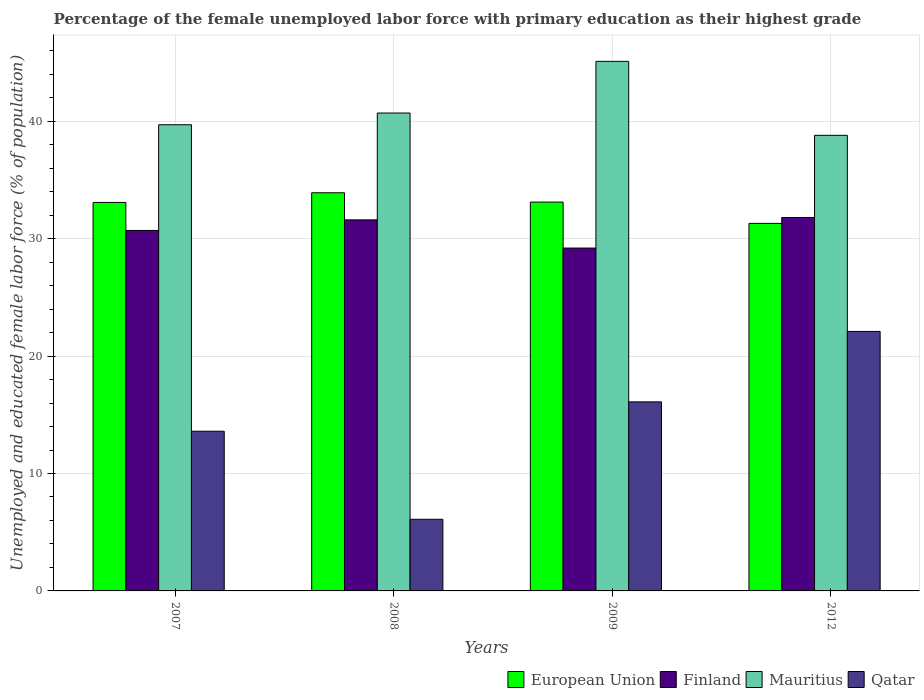How many different coloured bars are there?
Ensure brevity in your answer.  4. Are the number of bars per tick equal to the number of legend labels?
Offer a very short reply. Yes. How many bars are there on the 3rd tick from the left?
Your response must be concise. 4. What is the label of the 1st group of bars from the left?
Ensure brevity in your answer.  2007. What is the percentage of the unemployed female labor force with primary education in Finland in 2007?
Make the answer very short. 30.7. Across all years, what is the maximum percentage of the unemployed female labor force with primary education in Mauritius?
Your answer should be very brief. 45.1. Across all years, what is the minimum percentage of the unemployed female labor force with primary education in Finland?
Provide a succinct answer. 29.2. In which year was the percentage of the unemployed female labor force with primary education in Mauritius maximum?
Provide a succinct answer. 2009. In which year was the percentage of the unemployed female labor force with primary education in Finland minimum?
Give a very brief answer. 2009. What is the total percentage of the unemployed female labor force with primary education in Finland in the graph?
Offer a very short reply. 123.3. What is the difference between the percentage of the unemployed female labor force with primary education in Finland in 2008 and that in 2009?
Provide a succinct answer. 2.4. What is the difference between the percentage of the unemployed female labor force with primary education in Mauritius in 2008 and the percentage of the unemployed female labor force with primary education in Finland in 2012?
Your answer should be very brief. 8.9. What is the average percentage of the unemployed female labor force with primary education in European Union per year?
Keep it short and to the point. 32.85. In the year 2008, what is the difference between the percentage of the unemployed female labor force with primary education in Qatar and percentage of the unemployed female labor force with primary education in Mauritius?
Your response must be concise. -34.6. In how many years, is the percentage of the unemployed female labor force with primary education in Finland greater than 30 %?
Your response must be concise. 3. What is the ratio of the percentage of the unemployed female labor force with primary education in Mauritius in 2008 to that in 2009?
Make the answer very short. 0.9. Is the percentage of the unemployed female labor force with primary education in Finland in 2009 less than that in 2012?
Your answer should be compact. Yes. Is the difference between the percentage of the unemployed female labor force with primary education in Qatar in 2009 and 2012 greater than the difference between the percentage of the unemployed female labor force with primary education in Mauritius in 2009 and 2012?
Make the answer very short. No. What is the difference between the highest and the second highest percentage of the unemployed female labor force with primary education in Mauritius?
Your answer should be compact. 4.4. What is the difference between the highest and the lowest percentage of the unemployed female labor force with primary education in Qatar?
Your response must be concise. 16. In how many years, is the percentage of the unemployed female labor force with primary education in Qatar greater than the average percentage of the unemployed female labor force with primary education in Qatar taken over all years?
Provide a short and direct response. 2. Is the sum of the percentage of the unemployed female labor force with primary education in Finland in 2008 and 2009 greater than the maximum percentage of the unemployed female labor force with primary education in Mauritius across all years?
Offer a terse response. Yes. Is it the case that in every year, the sum of the percentage of the unemployed female labor force with primary education in European Union and percentage of the unemployed female labor force with primary education in Qatar is greater than the sum of percentage of the unemployed female labor force with primary education in Finland and percentage of the unemployed female labor force with primary education in Mauritius?
Offer a terse response. No. What does the 3rd bar from the right in 2008 represents?
Ensure brevity in your answer.  Finland. Is it the case that in every year, the sum of the percentage of the unemployed female labor force with primary education in Finland and percentage of the unemployed female labor force with primary education in Mauritius is greater than the percentage of the unemployed female labor force with primary education in Qatar?
Provide a succinct answer. Yes. What is the difference between two consecutive major ticks on the Y-axis?
Your answer should be compact. 10. How many legend labels are there?
Your answer should be very brief. 4. What is the title of the graph?
Ensure brevity in your answer.  Percentage of the female unemployed labor force with primary education as their highest grade. What is the label or title of the X-axis?
Ensure brevity in your answer.  Years. What is the label or title of the Y-axis?
Keep it short and to the point. Unemployed and educated female labor force (% of population). What is the Unemployed and educated female labor force (% of population) of European Union in 2007?
Offer a terse response. 33.08. What is the Unemployed and educated female labor force (% of population) in Finland in 2007?
Offer a very short reply. 30.7. What is the Unemployed and educated female labor force (% of population) in Mauritius in 2007?
Keep it short and to the point. 39.7. What is the Unemployed and educated female labor force (% of population) of Qatar in 2007?
Give a very brief answer. 13.6. What is the Unemployed and educated female labor force (% of population) in European Union in 2008?
Make the answer very short. 33.91. What is the Unemployed and educated female labor force (% of population) of Finland in 2008?
Your answer should be very brief. 31.6. What is the Unemployed and educated female labor force (% of population) of Mauritius in 2008?
Offer a very short reply. 40.7. What is the Unemployed and educated female labor force (% of population) in Qatar in 2008?
Make the answer very short. 6.1. What is the Unemployed and educated female labor force (% of population) of European Union in 2009?
Provide a succinct answer. 33.11. What is the Unemployed and educated female labor force (% of population) in Finland in 2009?
Make the answer very short. 29.2. What is the Unemployed and educated female labor force (% of population) of Mauritius in 2009?
Your response must be concise. 45.1. What is the Unemployed and educated female labor force (% of population) of Qatar in 2009?
Ensure brevity in your answer.  16.1. What is the Unemployed and educated female labor force (% of population) of European Union in 2012?
Offer a very short reply. 31.3. What is the Unemployed and educated female labor force (% of population) in Finland in 2012?
Ensure brevity in your answer.  31.8. What is the Unemployed and educated female labor force (% of population) in Mauritius in 2012?
Keep it short and to the point. 38.8. What is the Unemployed and educated female labor force (% of population) in Qatar in 2012?
Ensure brevity in your answer.  22.1. Across all years, what is the maximum Unemployed and educated female labor force (% of population) in European Union?
Your answer should be very brief. 33.91. Across all years, what is the maximum Unemployed and educated female labor force (% of population) of Finland?
Give a very brief answer. 31.8. Across all years, what is the maximum Unemployed and educated female labor force (% of population) of Mauritius?
Give a very brief answer. 45.1. Across all years, what is the maximum Unemployed and educated female labor force (% of population) of Qatar?
Keep it short and to the point. 22.1. Across all years, what is the minimum Unemployed and educated female labor force (% of population) of European Union?
Your answer should be very brief. 31.3. Across all years, what is the minimum Unemployed and educated female labor force (% of population) of Finland?
Ensure brevity in your answer.  29.2. Across all years, what is the minimum Unemployed and educated female labor force (% of population) in Mauritius?
Give a very brief answer. 38.8. Across all years, what is the minimum Unemployed and educated female labor force (% of population) in Qatar?
Provide a succinct answer. 6.1. What is the total Unemployed and educated female labor force (% of population) in European Union in the graph?
Your answer should be very brief. 131.41. What is the total Unemployed and educated female labor force (% of population) of Finland in the graph?
Offer a terse response. 123.3. What is the total Unemployed and educated female labor force (% of population) in Mauritius in the graph?
Give a very brief answer. 164.3. What is the total Unemployed and educated female labor force (% of population) of Qatar in the graph?
Keep it short and to the point. 57.9. What is the difference between the Unemployed and educated female labor force (% of population) in European Union in 2007 and that in 2008?
Your answer should be very brief. -0.82. What is the difference between the Unemployed and educated female labor force (% of population) in European Union in 2007 and that in 2009?
Provide a succinct answer. -0.03. What is the difference between the Unemployed and educated female labor force (% of population) in Finland in 2007 and that in 2009?
Provide a short and direct response. 1.5. What is the difference between the Unemployed and educated female labor force (% of population) in Mauritius in 2007 and that in 2009?
Provide a succinct answer. -5.4. What is the difference between the Unemployed and educated female labor force (% of population) of European Union in 2007 and that in 2012?
Give a very brief answer. 1.78. What is the difference between the Unemployed and educated female labor force (% of population) of Mauritius in 2007 and that in 2012?
Make the answer very short. 0.9. What is the difference between the Unemployed and educated female labor force (% of population) in Qatar in 2007 and that in 2012?
Keep it short and to the point. -8.5. What is the difference between the Unemployed and educated female labor force (% of population) of European Union in 2008 and that in 2009?
Give a very brief answer. 0.79. What is the difference between the Unemployed and educated female labor force (% of population) of Mauritius in 2008 and that in 2009?
Your answer should be compact. -4.4. What is the difference between the Unemployed and educated female labor force (% of population) of European Union in 2008 and that in 2012?
Provide a succinct answer. 2.61. What is the difference between the Unemployed and educated female labor force (% of population) in Finland in 2008 and that in 2012?
Offer a very short reply. -0.2. What is the difference between the Unemployed and educated female labor force (% of population) in Mauritius in 2008 and that in 2012?
Provide a succinct answer. 1.9. What is the difference between the Unemployed and educated female labor force (% of population) in European Union in 2009 and that in 2012?
Give a very brief answer. 1.81. What is the difference between the Unemployed and educated female labor force (% of population) of Finland in 2009 and that in 2012?
Ensure brevity in your answer.  -2.6. What is the difference between the Unemployed and educated female labor force (% of population) of Qatar in 2009 and that in 2012?
Offer a terse response. -6. What is the difference between the Unemployed and educated female labor force (% of population) of European Union in 2007 and the Unemployed and educated female labor force (% of population) of Finland in 2008?
Provide a short and direct response. 1.48. What is the difference between the Unemployed and educated female labor force (% of population) of European Union in 2007 and the Unemployed and educated female labor force (% of population) of Mauritius in 2008?
Provide a short and direct response. -7.62. What is the difference between the Unemployed and educated female labor force (% of population) of European Union in 2007 and the Unemployed and educated female labor force (% of population) of Qatar in 2008?
Your response must be concise. 26.98. What is the difference between the Unemployed and educated female labor force (% of population) in Finland in 2007 and the Unemployed and educated female labor force (% of population) in Mauritius in 2008?
Offer a very short reply. -10. What is the difference between the Unemployed and educated female labor force (% of population) in Finland in 2007 and the Unemployed and educated female labor force (% of population) in Qatar in 2008?
Your answer should be very brief. 24.6. What is the difference between the Unemployed and educated female labor force (% of population) in Mauritius in 2007 and the Unemployed and educated female labor force (% of population) in Qatar in 2008?
Make the answer very short. 33.6. What is the difference between the Unemployed and educated female labor force (% of population) of European Union in 2007 and the Unemployed and educated female labor force (% of population) of Finland in 2009?
Ensure brevity in your answer.  3.88. What is the difference between the Unemployed and educated female labor force (% of population) of European Union in 2007 and the Unemployed and educated female labor force (% of population) of Mauritius in 2009?
Your answer should be compact. -12.02. What is the difference between the Unemployed and educated female labor force (% of population) of European Union in 2007 and the Unemployed and educated female labor force (% of population) of Qatar in 2009?
Ensure brevity in your answer.  16.98. What is the difference between the Unemployed and educated female labor force (% of population) of Finland in 2007 and the Unemployed and educated female labor force (% of population) of Mauritius in 2009?
Provide a succinct answer. -14.4. What is the difference between the Unemployed and educated female labor force (% of population) in Finland in 2007 and the Unemployed and educated female labor force (% of population) in Qatar in 2009?
Keep it short and to the point. 14.6. What is the difference between the Unemployed and educated female labor force (% of population) of Mauritius in 2007 and the Unemployed and educated female labor force (% of population) of Qatar in 2009?
Your response must be concise. 23.6. What is the difference between the Unemployed and educated female labor force (% of population) in European Union in 2007 and the Unemployed and educated female labor force (% of population) in Finland in 2012?
Keep it short and to the point. 1.28. What is the difference between the Unemployed and educated female labor force (% of population) in European Union in 2007 and the Unemployed and educated female labor force (% of population) in Mauritius in 2012?
Make the answer very short. -5.72. What is the difference between the Unemployed and educated female labor force (% of population) in European Union in 2007 and the Unemployed and educated female labor force (% of population) in Qatar in 2012?
Your answer should be very brief. 10.98. What is the difference between the Unemployed and educated female labor force (% of population) in Finland in 2007 and the Unemployed and educated female labor force (% of population) in Qatar in 2012?
Offer a terse response. 8.6. What is the difference between the Unemployed and educated female labor force (% of population) in European Union in 2008 and the Unemployed and educated female labor force (% of population) in Finland in 2009?
Make the answer very short. 4.71. What is the difference between the Unemployed and educated female labor force (% of population) in European Union in 2008 and the Unemployed and educated female labor force (% of population) in Mauritius in 2009?
Offer a very short reply. -11.19. What is the difference between the Unemployed and educated female labor force (% of population) of European Union in 2008 and the Unemployed and educated female labor force (% of population) of Qatar in 2009?
Your response must be concise. 17.81. What is the difference between the Unemployed and educated female labor force (% of population) of Finland in 2008 and the Unemployed and educated female labor force (% of population) of Mauritius in 2009?
Ensure brevity in your answer.  -13.5. What is the difference between the Unemployed and educated female labor force (% of population) in Finland in 2008 and the Unemployed and educated female labor force (% of population) in Qatar in 2009?
Offer a very short reply. 15.5. What is the difference between the Unemployed and educated female labor force (% of population) of Mauritius in 2008 and the Unemployed and educated female labor force (% of population) of Qatar in 2009?
Keep it short and to the point. 24.6. What is the difference between the Unemployed and educated female labor force (% of population) in European Union in 2008 and the Unemployed and educated female labor force (% of population) in Finland in 2012?
Your response must be concise. 2.11. What is the difference between the Unemployed and educated female labor force (% of population) in European Union in 2008 and the Unemployed and educated female labor force (% of population) in Mauritius in 2012?
Provide a short and direct response. -4.89. What is the difference between the Unemployed and educated female labor force (% of population) in European Union in 2008 and the Unemployed and educated female labor force (% of population) in Qatar in 2012?
Offer a terse response. 11.81. What is the difference between the Unemployed and educated female labor force (% of population) of European Union in 2009 and the Unemployed and educated female labor force (% of population) of Finland in 2012?
Give a very brief answer. 1.31. What is the difference between the Unemployed and educated female labor force (% of population) in European Union in 2009 and the Unemployed and educated female labor force (% of population) in Mauritius in 2012?
Keep it short and to the point. -5.69. What is the difference between the Unemployed and educated female labor force (% of population) of European Union in 2009 and the Unemployed and educated female labor force (% of population) of Qatar in 2012?
Provide a short and direct response. 11.01. What is the difference between the Unemployed and educated female labor force (% of population) in Finland in 2009 and the Unemployed and educated female labor force (% of population) in Mauritius in 2012?
Offer a very short reply. -9.6. What is the difference between the Unemployed and educated female labor force (% of population) of Finland in 2009 and the Unemployed and educated female labor force (% of population) of Qatar in 2012?
Give a very brief answer. 7.1. What is the average Unemployed and educated female labor force (% of population) of European Union per year?
Offer a very short reply. 32.85. What is the average Unemployed and educated female labor force (% of population) in Finland per year?
Your response must be concise. 30.82. What is the average Unemployed and educated female labor force (% of population) of Mauritius per year?
Give a very brief answer. 41.08. What is the average Unemployed and educated female labor force (% of population) in Qatar per year?
Ensure brevity in your answer.  14.47. In the year 2007, what is the difference between the Unemployed and educated female labor force (% of population) in European Union and Unemployed and educated female labor force (% of population) in Finland?
Provide a short and direct response. 2.38. In the year 2007, what is the difference between the Unemployed and educated female labor force (% of population) in European Union and Unemployed and educated female labor force (% of population) in Mauritius?
Your answer should be very brief. -6.62. In the year 2007, what is the difference between the Unemployed and educated female labor force (% of population) of European Union and Unemployed and educated female labor force (% of population) of Qatar?
Your response must be concise. 19.48. In the year 2007, what is the difference between the Unemployed and educated female labor force (% of population) of Finland and Unemployed and educated female labor force (% of population) of Qatar?
Your answer should be compact. 17.1. In the year 2007, what is the difference between the Unemployed and educated female labor force (% of population) of Mauritius and Unemployed and educated female labor force (% of population) of Qatar?
Ensure brevity in your answer.  26.1. In the year 2008, what is the difference between the Unemployed and educated female labor force (% of population) of European Union and Unemployed and educated female labor force (% of population) of Finland?
Provide a short and direct response. 2.31. In the year 2008, what is the difference between the Unemployed and educated female labor force (% of population) in European Union and Unemployed and educated female labor force (% of population) in Mauritius?
Your answer should be very brief. -6.79. In the year 2008, what is the difference between the Unemployed and educated female labor force (% of population) in European Union and Unemployed and educated female labor force (% of population) in Qatar?
Ensure brevity in your answer.  27.81. In the year 2008, what is the difference between the Unemployed and educated female labor force (% of population) in Finland and Unemployed and educated female labor force (% of population) in Mauritius?
Your answer should be very brief. -9.1. In the year 2008, what is the difference between the Unemployed and educated female labor force (% of population) in Finland and Unemployed and educated female labor force (% of population) in Qatar?
Your response must be concise. 25.5. In the year 2008, what is the difference between the Unemployed and educated female labor force (% of population) in Mauritius and Unemployed and educated female labor force (% of population) in Qatar?
Ensure brevity in your answer.  34.6. In the year 2009, what is the difference between the Unemployed and educated female labor force (% of population) in European Union and Unemployed and educated female labor force (% of population) in Finland?
Your answer should be very brief. 3.91. In the year 2009, what is the difference between the Unemployed and educated female labor force (% of population) of European Union and Unemployed and educated female labor force (% of population) of Mauritius?
Provide a short and direct response. -11.99. In the year 2009, what is the difference between the Unemployed and educated female labor force (% of population) in European Union and Unemployed and educated female labor force (% of population) in Qatar?
Keep it short and to the point. 17.01. In the year 2009, what is the difference between the Unemployed and educated female labor force (% of population) of Finland and Unemployed and educated female labor force (% of population) of Mauritius?
Give a very brief answer. -15.9. In the year 2009, what is the difference between the Unemployed and educated female labor force (% of population) in Finland and Unemployed and educated female labor force (% of population) in Qatar?
Offer a terse response. 13.1. In the year 2012, what is the difference between the Unemployed and educated female labor force (% of population) in European Union and Unemployed and educated female labor force (% of population) in Finland?
Provide a succinct answer. -0.5. In the year 2012, what is the difference between the Unemployed and educated female labor force (% of population) of European Union and Unemployed and educated female labor force (% of population) of Mauritius?
Provide a short and direct response. -7.5. In the year 2012, what is the difference between the Unemployed and educated female labor force (% of population) in European Union and Unemployed and educated female labor force (% of population) in Qatar?
Make the answer very short. 9.2. What is the ratio of the Unemployed and educated female labor force (% of population) of European Union in 2007 to that in 2008?
Ensure brevity in your answer.  0.98. What is the ratio of the Unemployed and educated female labor force (% of population) in Finland in 2007 to that in 2008?
Your response must be concise. 0.97. What is the ratio of the Unemployed and educated female labor force (% of population) in Mauritius in 2007 to that in 2008?
Make the answer very short. 0.98. What is the ratio of the Unemployed and educated female labor force (% of population) of Qatar in 2007 to that in 2008?
Provide a succinct answer. 2.23. What is the ratio of the Unemployed and educated female labor force (% of population) of European Union in 2007 to that in 2009?
Keep it short and to the point. 1. What is the ratio of the Unemployed and educated female labor force (% of population) in Finland in 2007 to that in 2009?
Your answer should be compact. 1.05. What is the ratio of the Unemployed and educated female labor force (% of population) in Mauritius in 2007 to that in 2009?
Your answer should be compact. 0.88. What is the ratio of the Unemployed and educated female labor force (% of population) of Qatar in 2007 to that in 2009?
Give a very brief answer. 0.84. What is the ratio of the Unemployed and educated female labor force (% of population) in European Union in 2007 to that in 2012?
Give a very brief answer. 1.06. What is the ratio of the Unemployed and educated female labor force (% of population) of Finland in 2007 to that in 2012?
Ensure brevity in your answer.  0.97. What is the ratio of the Unemployed and educated female labor force (% of population) of Mauritius in 2007 to that in 2012?
Make the answer very short. 1.02. What is the ratio of the Unemployed and educated female labor force (% of population) of Qatar in 2007 to that in 2012?
Ensure brevity in your answer.  0.62. What is the ratio of the Unemployed and educated female labor force (% of population) of European Union in 2008 to that in 2009?
Your response must be concise. 1.02. What is the ratio of the Unemployed and educated female labor force (% of population) in Finland in 2008 to that in 2009?
Ensure brevity in your answer.  1.08. What is the ratio of the Unemployed and educated female labor force (% of population) in Mauritius in 2008 to that in 2009?
Keep it short and to the point. 0.9. What is the ratio of the Unemployed and educated female labor force (% of population) in Qatar in 2008 to that in 2009?
Ensure brevity in your answer.  0.38. What is the ratio of the Unemployed and educated female labor force (% of population) of Mauritius in 2008 to that in 2012?
Keep it short and to the point. 1.05. What is the ratio of the Unemployed and educated female labor force (% of population) in Qatar in 2008 to that in 2012?
Offer a terse response. 0.28. What is the ratio of the Unemployed and educated female labor force (% of population) of European Union in 2009 to that in 2012?
Your answer should be compact. 1.06. What is the ratio of the Unemployed and educated female labor force (% of population) in Finland in 2009 to that in 2012?
Offer a very short reply. 0.92. What is the ratio of the Unemployed and educated female labor force (% of population) in Mauritius in 2009 to that in 2012?
Your answer should be compact. 1.16. What is the ratio of the Unemployed and educated female labor force (% of population) in Qatar in 2009 to that in 2012?
Provide a succinct answer. 0.73. What is the difference between the highest and the second highest Unemployed and educated female labor force (% of population) in European Union?
Your answer should be very brief. 0.79. What is the difference between the highest and the second highest Unemployed and educated female labor force (% of population) of Mauritius?
Your response must be concise. 4.4. What is the difference between the highest and the lowest Unemployed and educated female labor force (% of population) in European Union?
Your answer should be very brief. 2.61. What is the difference between the highest and the lowest Unemployed and educated female labor force (% of population) of Finland?
Your answer should be very brief. 2.6. 